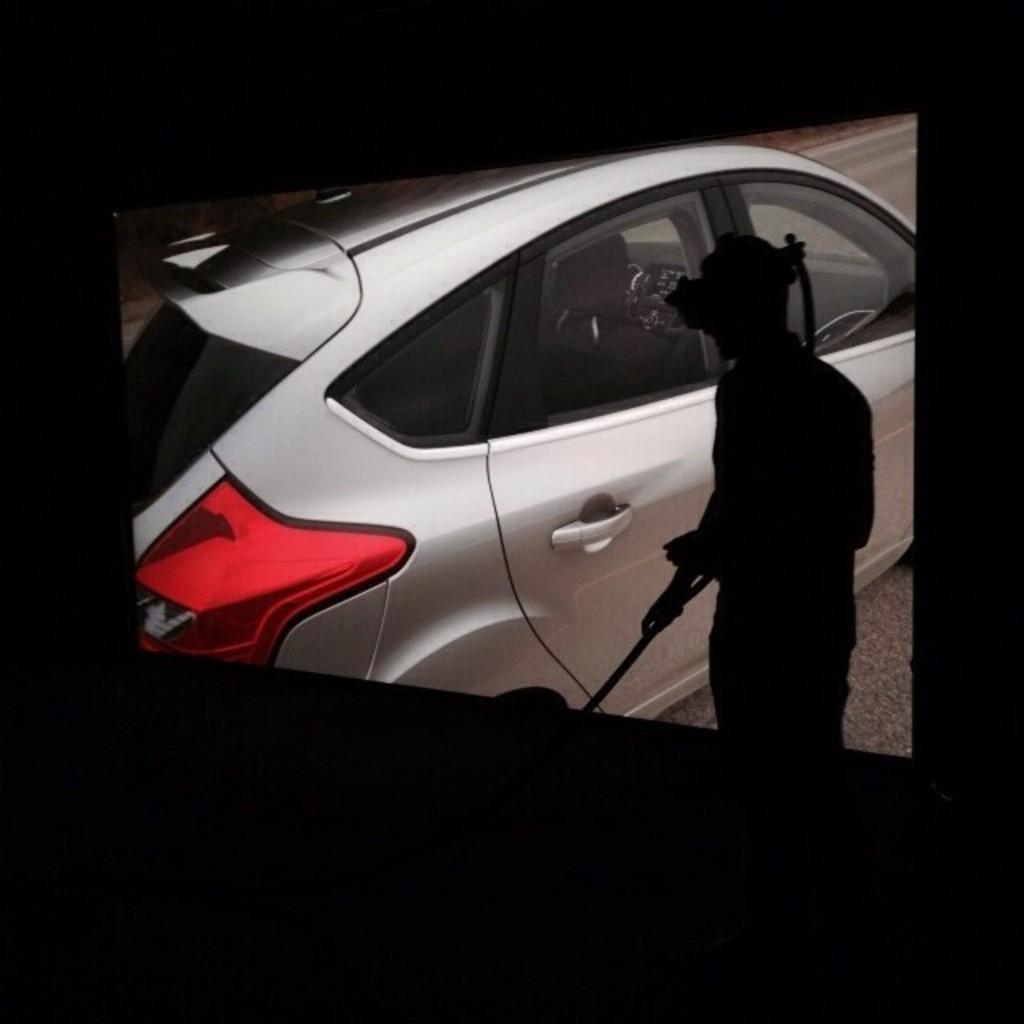What is present in the image along with the person? There is a vehicle in the image. Where are the person and the vehicle located? Both the person and the vehicle are on the road. What color are the chairs in the image? There are no chairs present in the image. 